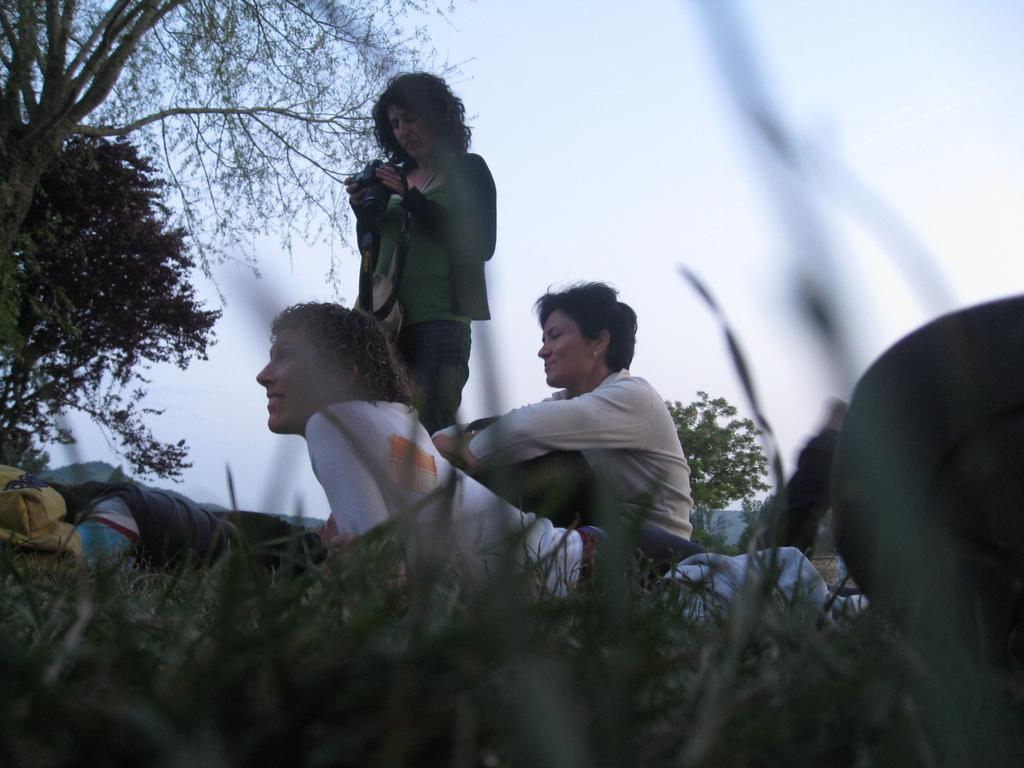Can you describe this image briefly? In this image in the center there are some people, and bags and one woman is holding a camera. And at the bottom there is grass, and on the right side there is some object. And in the background there are trees, at the top there is sky. 